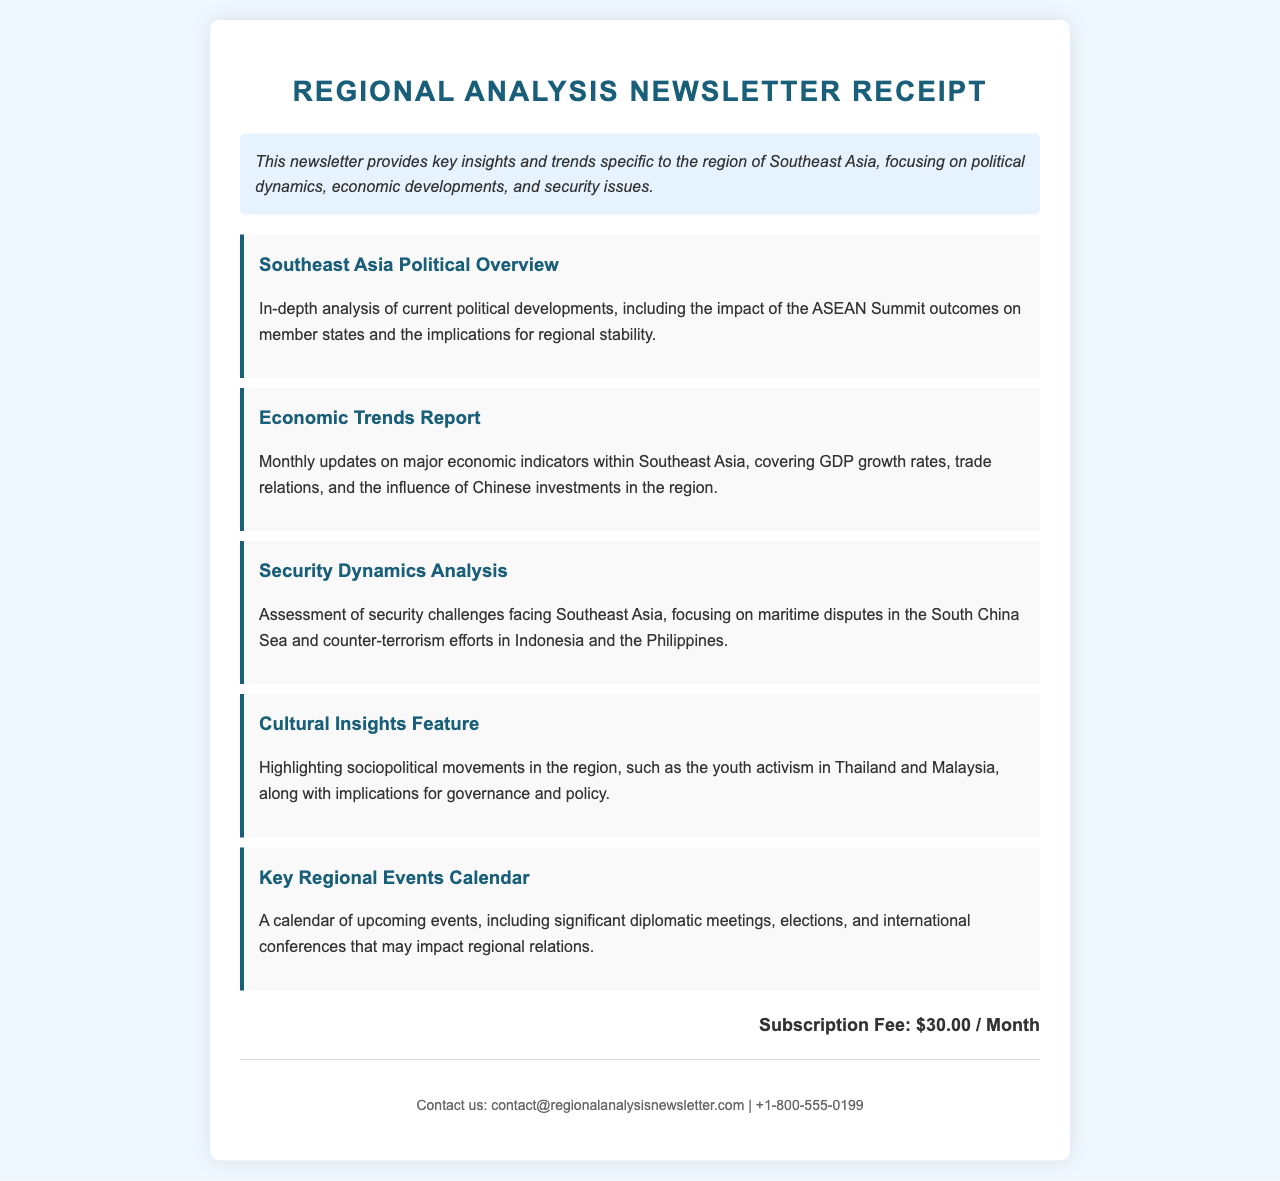What is the title of the document? The title is indicated at the top of the receipt, specifying what the document is about.
Answer: Regional Analysis Newsletter Receipt What is the subscription fee? The subscription fee is stated clearly in the document's fee section.
Answer: $30.00 / Month What region does the newsletter focus on? The description provides information on the specific region that the newsletter covers.
Answer: Southeast Asia What are the two main topics covered in the newsletter? The description outlines the major themes of the newsletter, which include political dynamics and economic developments.
Answer: Political dynamics, economic developments What is included in the Key Regional Events Calendar? The document mentions types of events listed in the calendar that might influence regional relations.
Answer: Significant diplomatic meetings, elections, international conferences What is one of the key insights related to security? The document contains an analysis section that highlights major security challenges in the region.
Answer: Maritime disputes in the South China Sea What is a featured sociopolitical movement mentioned? The newsletter highlights particular movements that are relevant to governance and policy in the region.
Answer: Youth activism in Thailand and Malaysia What type of report is provided with economic updates? The newsletter lists a specific report that covers economic indicators for Southeast Asia.
Answer: Economic Trends Report What is the contact email provided in the document? The contact section includes an email address for inquiries related to the newsletter.
Answer: contact@regionalanalysisnewsletter.com 